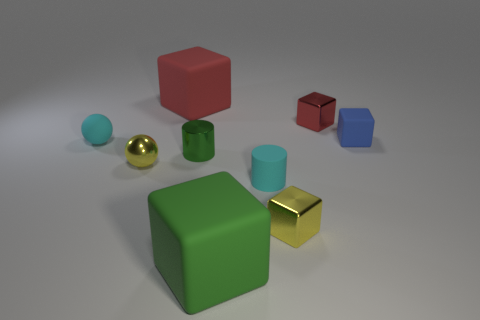There is a tiny cylinder that is the same color as the rubber ball; what material is it?
Offer a very short reply. Rubber. What is the size of the green rubber block?
Give a very brief answer. Large. What number of things are small blue cubes or yellow objects that are in front of the rubber cylinder?
Give a very brief answer. 2. How many other objects are there of the same color as the small matte block?
Offer a very short reply. 0. Does the blue matte cube have the same size as the red cube on the left side of the small matte cylinder?
Provide a succinct answer. No. Does the green shiny cylinder left of the yellow metallic block have the same size as the tiny yellow block?
Your answer should be compact. Yes. What number of other things are there of the same material as the large red thing
Your answer should be compact. 4. Are there an equal number of small green cylinders behind the small cyan rubber ball and small blue rubber things that are in front of the small rubber cylinder?
Make the answer very short. Yes. There is a large matte object that is in front of the small cyan thing that is right of the matte object to the left of the red rubber cube; what color is it?
Offer a terse response. Green. What shape is the tiny yellow metallic object behind the matte cylinder?
Offer a very short reply. Sphere. 